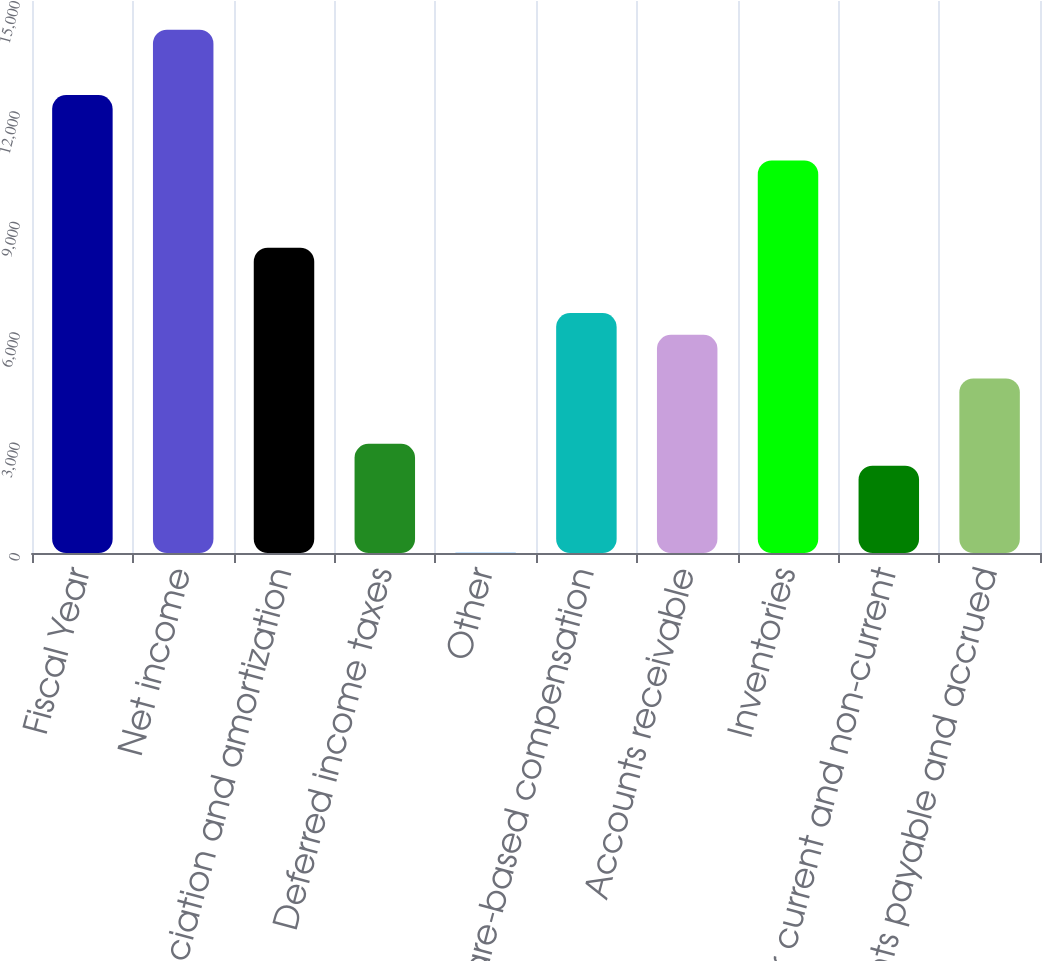Convert chart. <chart><loc_0><loc_0><loc_500><loc_500><bar_chart><fcel>Fiscal Year<fcel>Net income<fcel>Depreciation and amortization<fcel>Deferred income taxes<fcel>Other<fcel>Share-based compensation<fcel>Accounts receivable<fcel>Inventories<fcel>Other current and non-current<fcel>Accounts payable and accrued<nl><fcel>12444.4<fcel>14221.6<fcel>8297.6<fcel>2966<fcel>4<fcel>6520.4<fcel>5928<fcel>10667.2<fcel>2373.6<fcel>4743.2<nl></chart> 